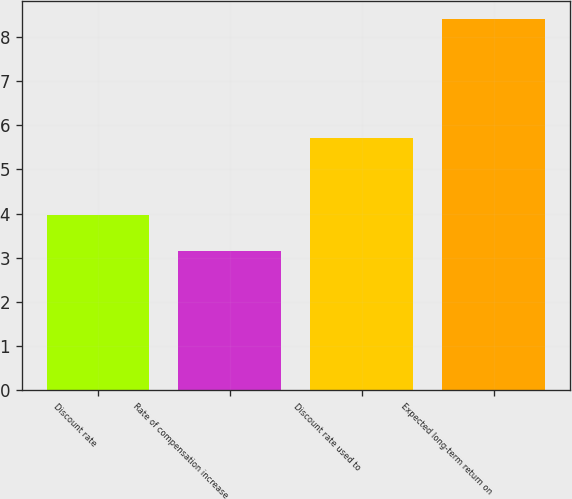Convert chart. <chart><loc_0><loc_0><loc_500><loc_500><bar_chart><fcel>Discount rate<fcel>Rate of compensation increase<fcel>Discount rate used to<fcel>Expected long-term return on<nl><fcel>3.97<fcel>3.16<fcel>5.71<fcel>8.4<nl></chart> 